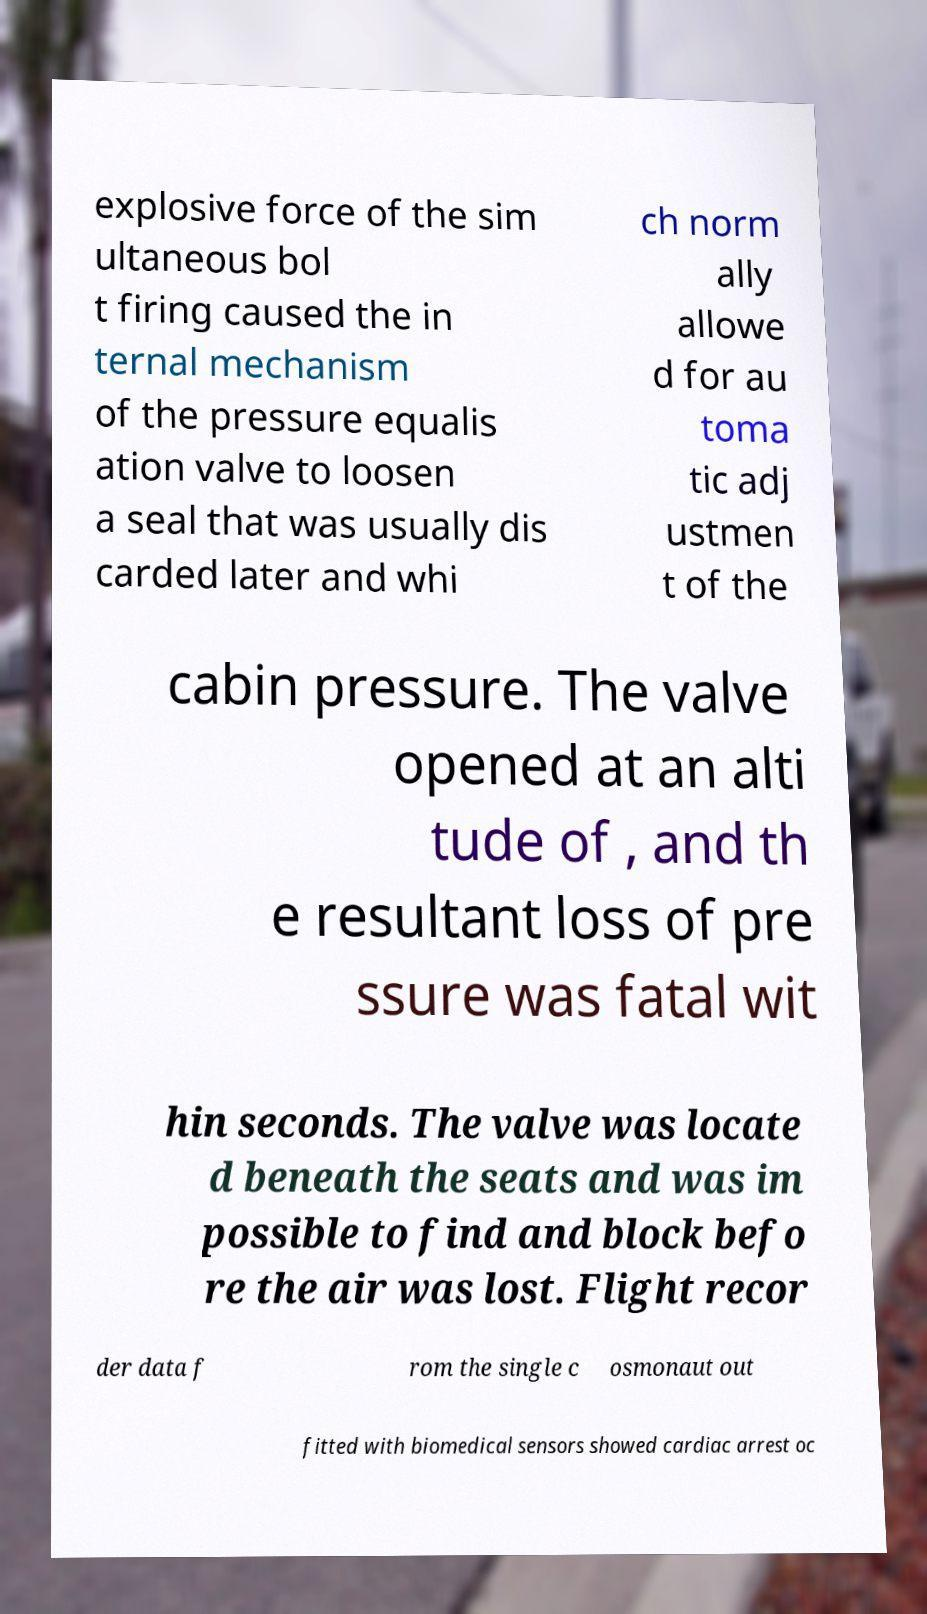I need the written content from this picture converted into text. Can you do that? explosive force of the sim ultaneous bol t firing caused the in ternal mechanism of the pressure equalis ation valve to loosen a seal that was usually dis carded later and whi ch norm ally allowe d for au toma tic adj ustmen t of the cabin pressure. The valve opened at an alti tude of , and th e resultant loss of pre ssure was fatal wit hin seconds. The valve was locate d beneath the seats and was im possible to find and block befo re the air was lost. Flight recor der data f rom the single c osmonaut out fitted with biomedical sensors showed cardiac arrest oc 